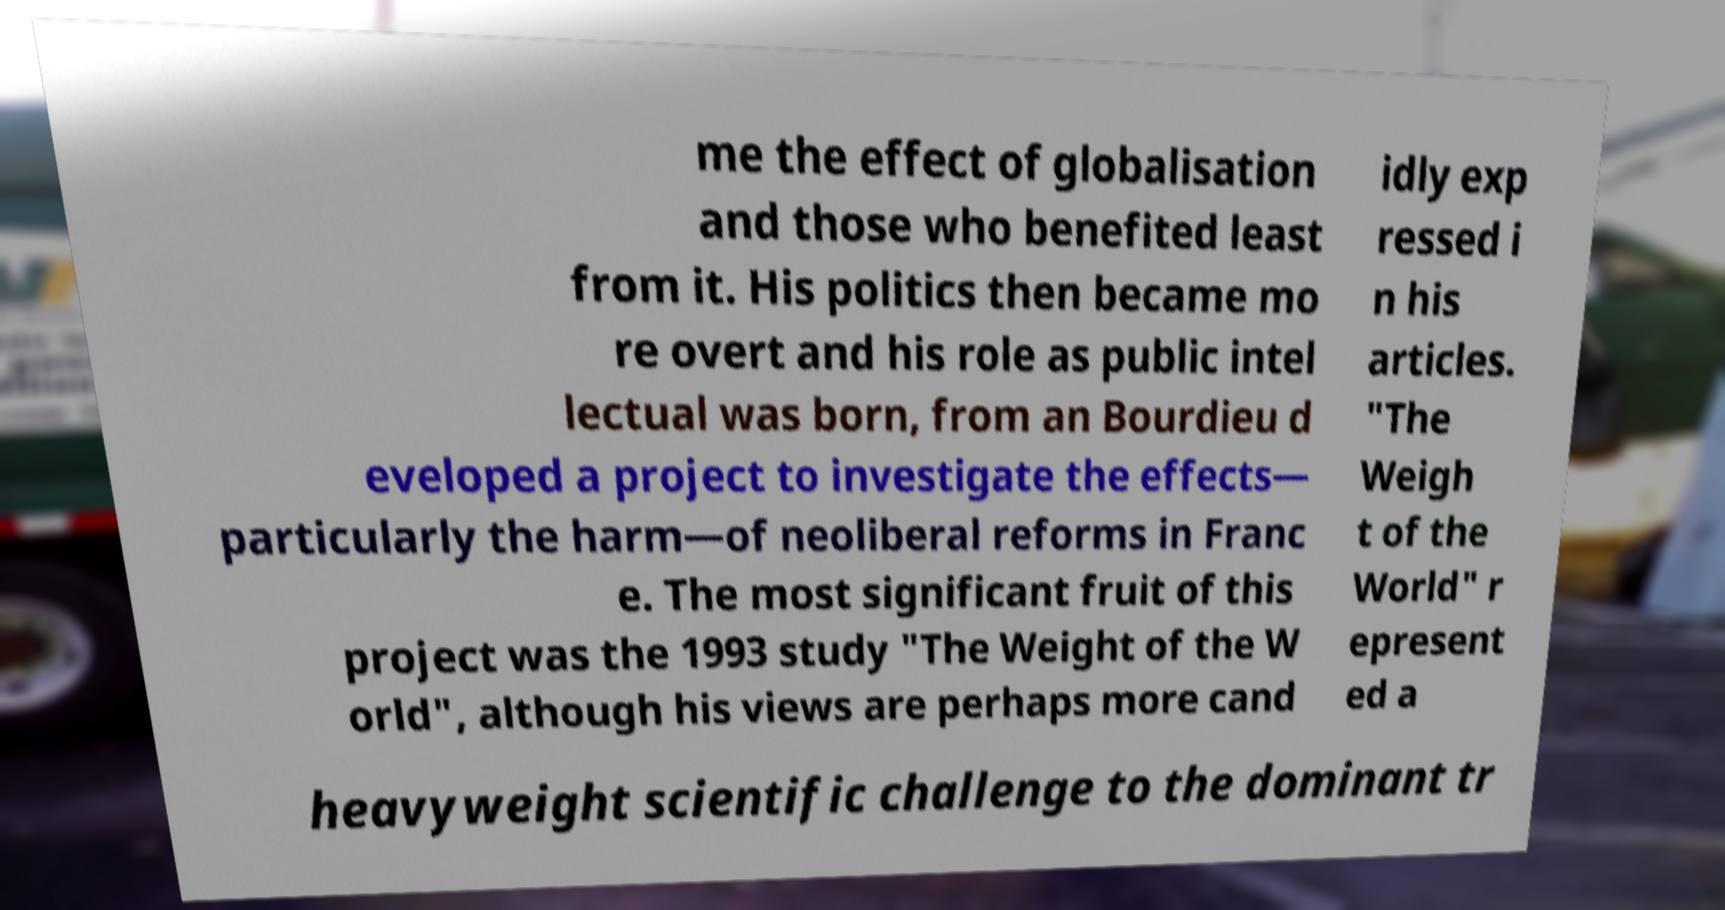I need the written content from this picture converted into text. Can you do that? me the effect of globalisation and those who benefited least from it. His politics then became mo re overt and his role as public intel lectual was born, from an Bourdieu d eveloped a project to investigate the effects— particularly the harm—of neoliberal reforms in Franc e. The most significant fruit of this project was the 1993 study "The Weight of the W orld", although his views are perhaps more cand idly exp ressed i n his articles. "The Weigh t of the World" r epresent ed a heavyweight scientific challenge to the dominant tr 